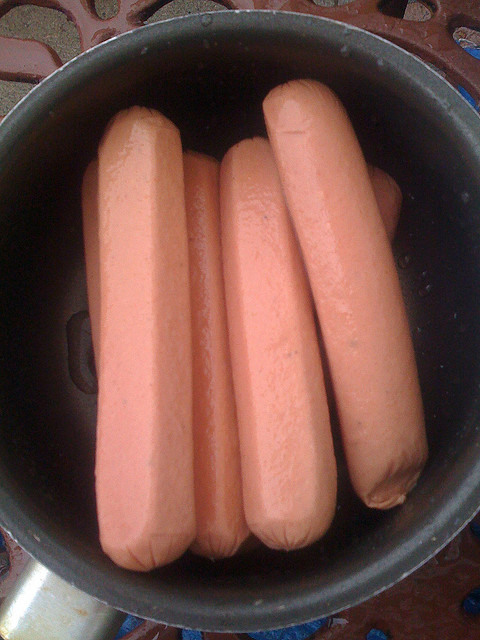Could you suggest healthier alternatives to this food? Certainly! Healthier alternatives to hot dogs could include turkey or chicken sausages, which often have less fat and sodium. Plant-based sausages made from ingredients like tofu, black beans, or lentils are also good options, offering protein without the saturated fat or sodium. For those not avoiding meat but looking for healthier options, choosing hot dogs made from grass-fed beef or free-range pork with no added nitrates or nitrites can be better choices. 